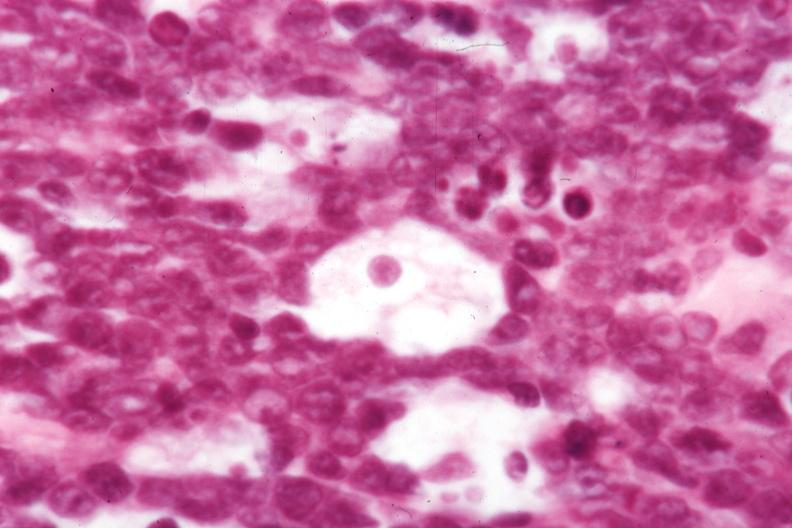how is not the best histology but morphology for dx?
Answer the question using a single word or phrase. Typical 